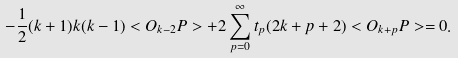<formula> <loc_0><loc_0><loc_500><loc_500>- \frac { 1 } { 2 } ( k + 1 ) k ( k - 1 ) < O _ { k - 2 } P > + 2 \sum _ { p = 0 } ^ { \infty } t _ { p } ( 2 k + p + 2 ) < O _ { k + p } P > = 0 .</formula> 